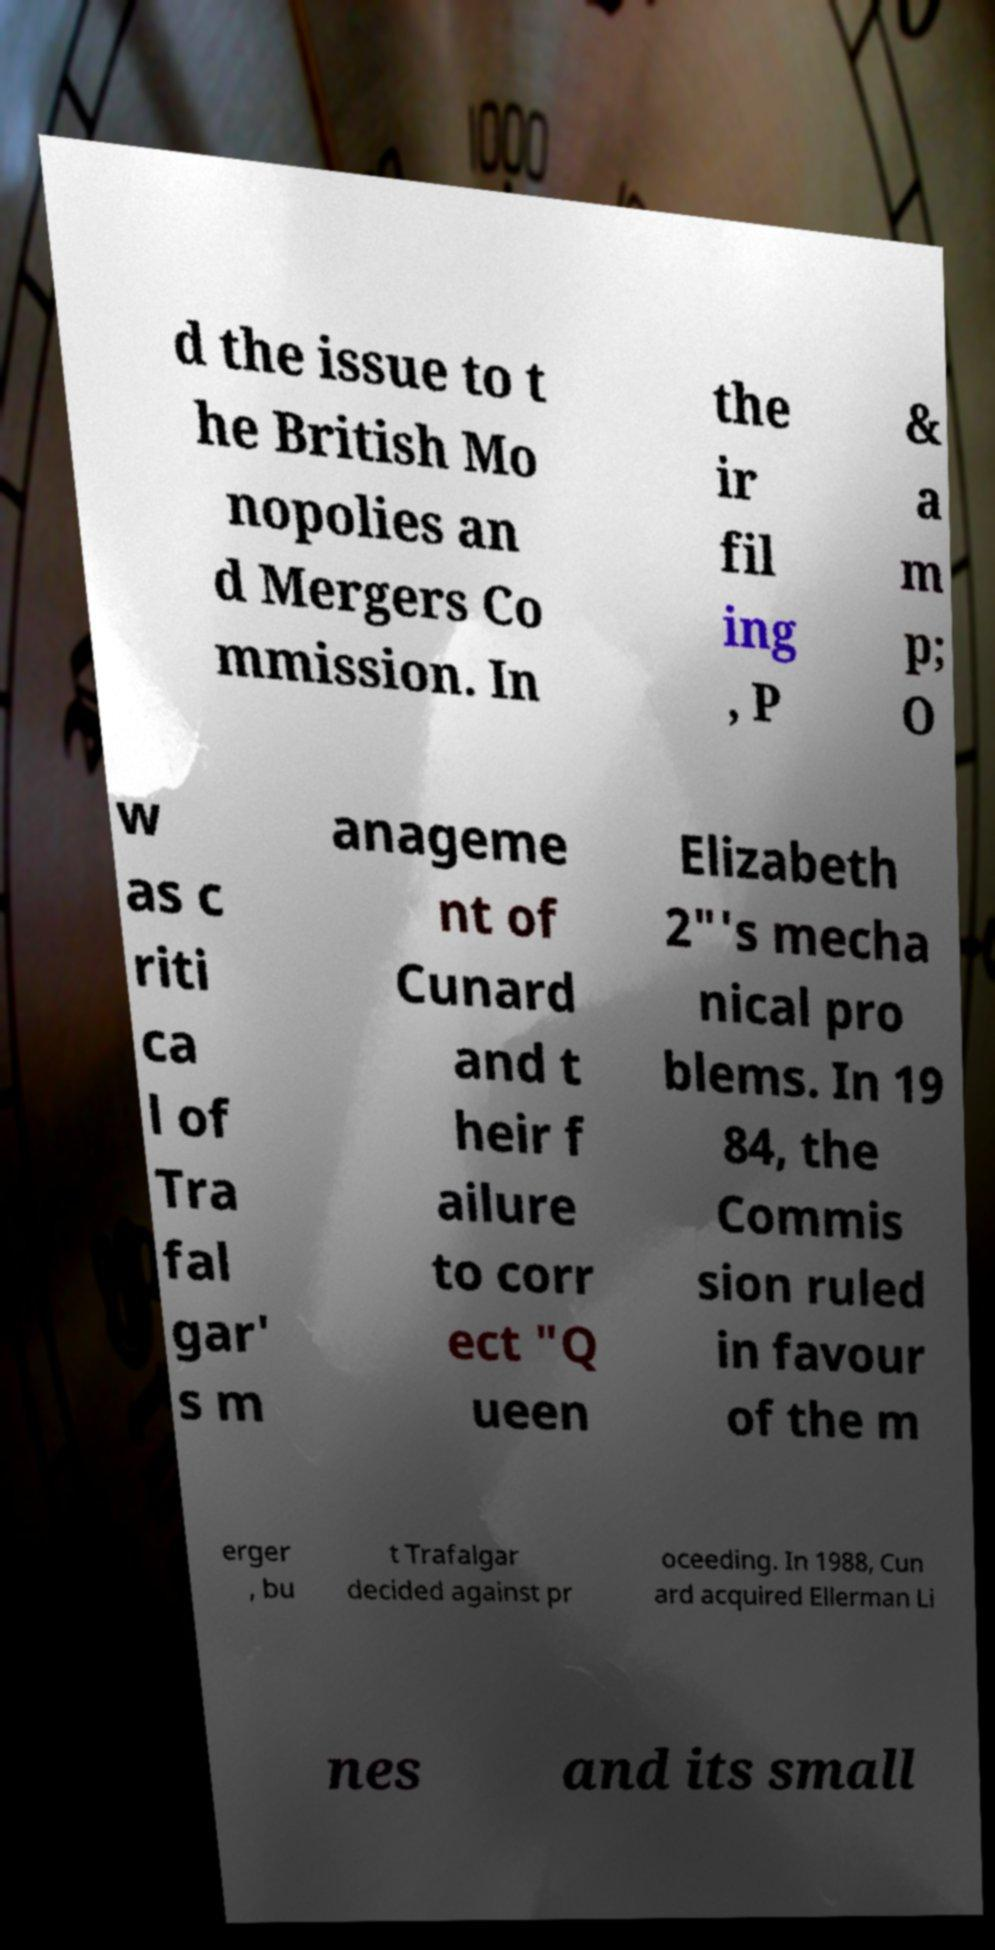Please read and relay the text visible in this image. What does it say? d the issue to t he British Mo nopolies an d Mergers Co mmission. In the ir fil ing , P & a m p; O w as c riti ca l of Tra fal gar' s m anageme nt of Cunard and t heir f ailure to corr ect "Q ueen Elizabeth 2"'s mecha nical pro blems. In 19 84, the Commis sion ruled in favour of the m erger , bu t Trafalgar decided against pr oceeding. In 1988, Cun ard acquired Ellerman Li nes and its small 